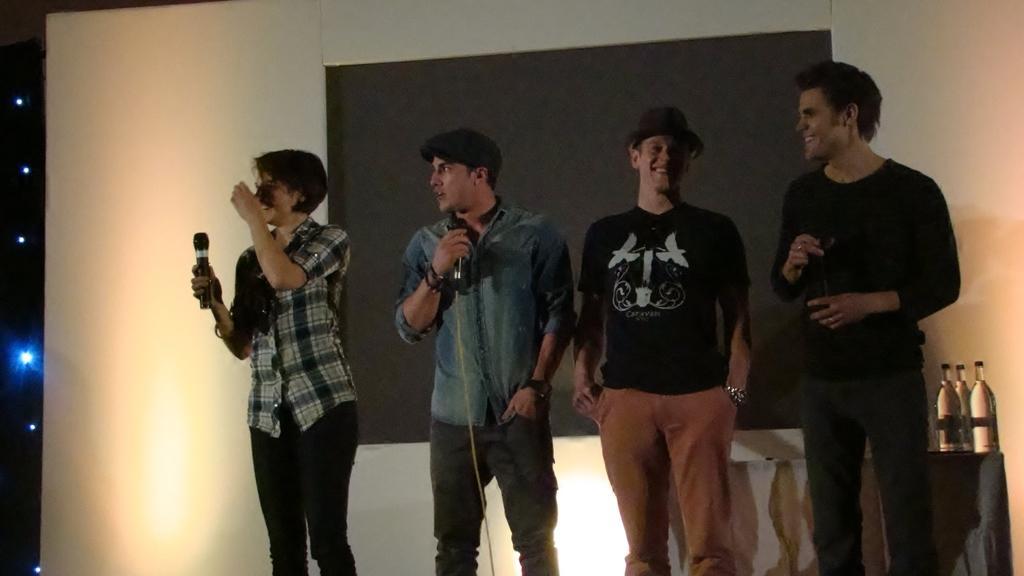Can you describe this image briefly? Here in this picture we can see a group of people standing on the floor over there and they are holding microphones in their hands, behind them we can see table, on which we can see water bottles present and we can also see a screen present behind them and we can see all of them are smiling, the person in the middle is wearing a hat on him and on the left side we can see lights present all over there. 